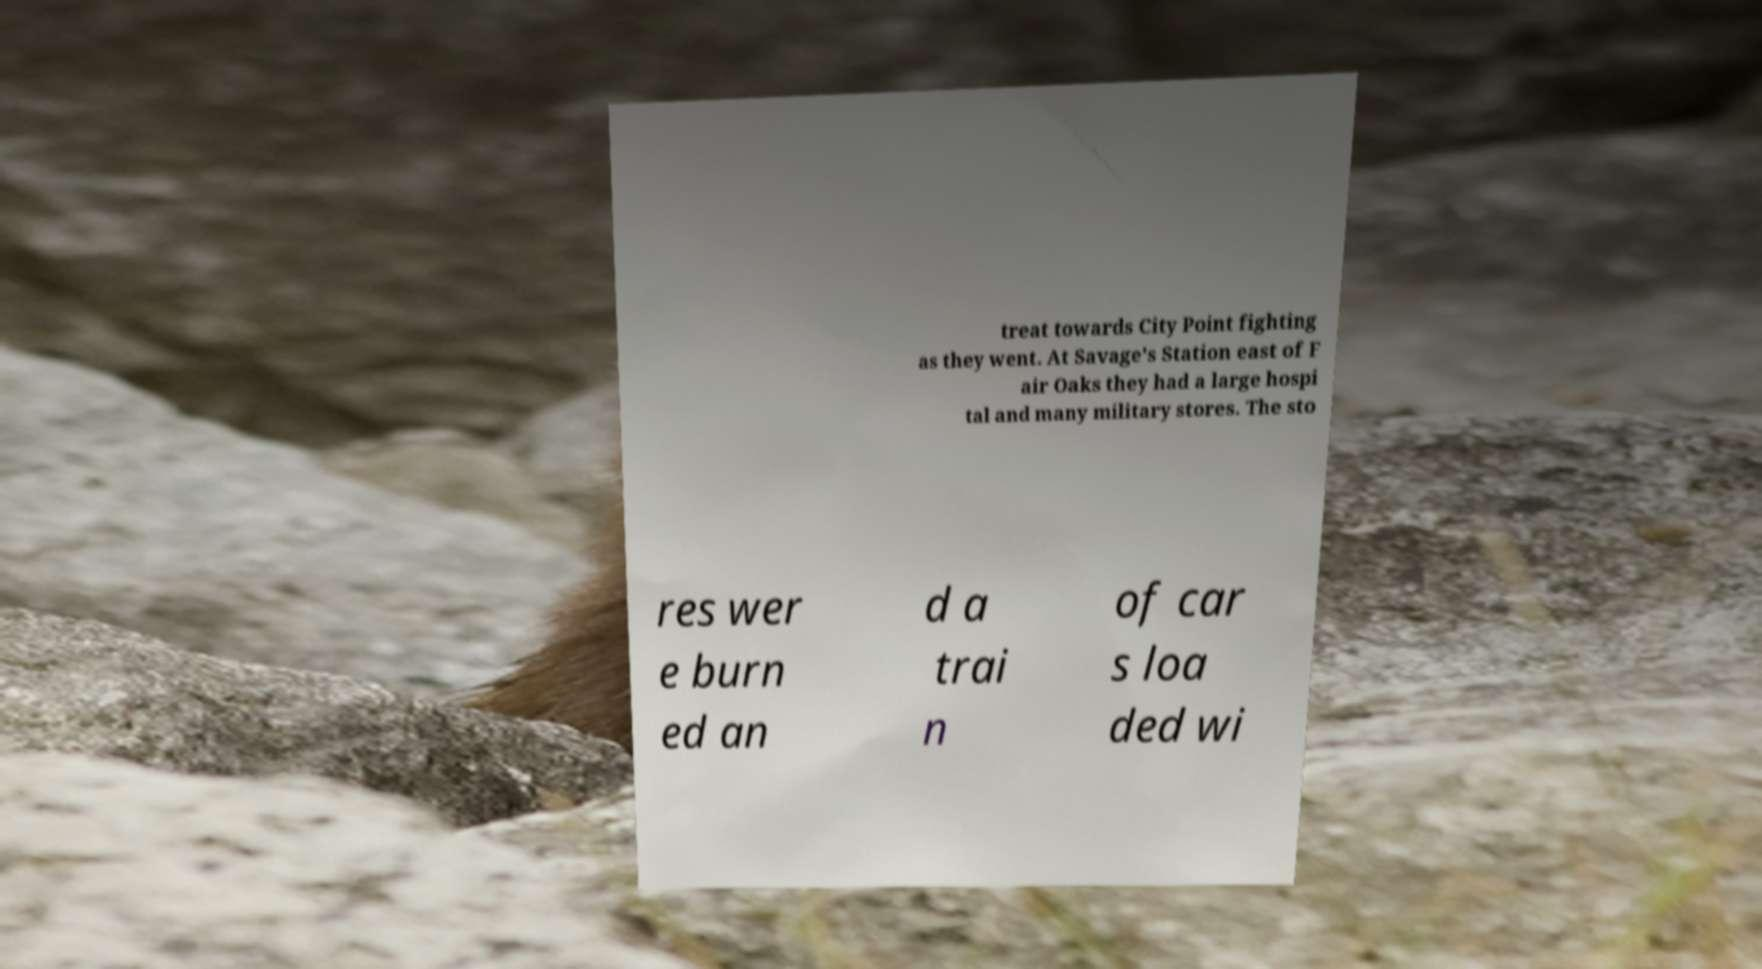I need the written content from this picture converted into text. Can you do that? treat towards City Point fighting as they went. At Savage's Station east of F air Oaks they had a large hospi tal and many military stores. The sto res wer e burn ed an d a trai n of car s loa ded wi 